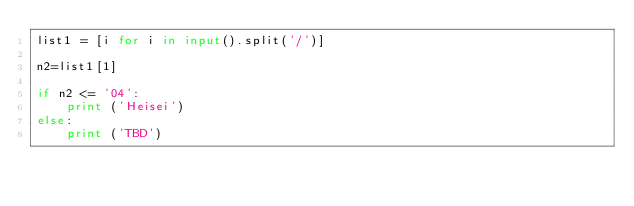Convert code to text. <code><loc_0><loc_0><loc_500><loc_500><_Python_>list1 = [i for i in input().split('/')]

n2=list1[1]

if n2 <= '04':
    print ('Heisei')
else:
    print ('TBD')</code> 